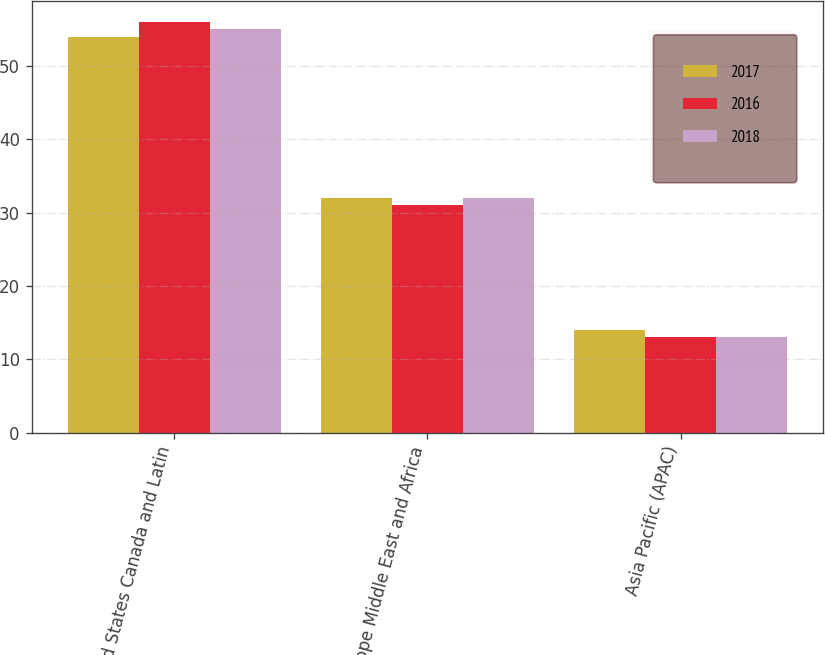Convert chart. <chart><loc_0><loc_0><loc_500><loc_500><stacked_bar_chart><ecel><fcel>United States Canada and Latin<fcel>Europe Middle East and Africa<fcel>Asia Pacific (APAC)<nl><fcel>2017<fcel>54<fcel>32<fcel>14<nl><fcel>2016<fcel>56<fcel>31<fcel>13<nl><fcel>2018<fcel>55<fcel>32<fcel>13<nl></chart> 